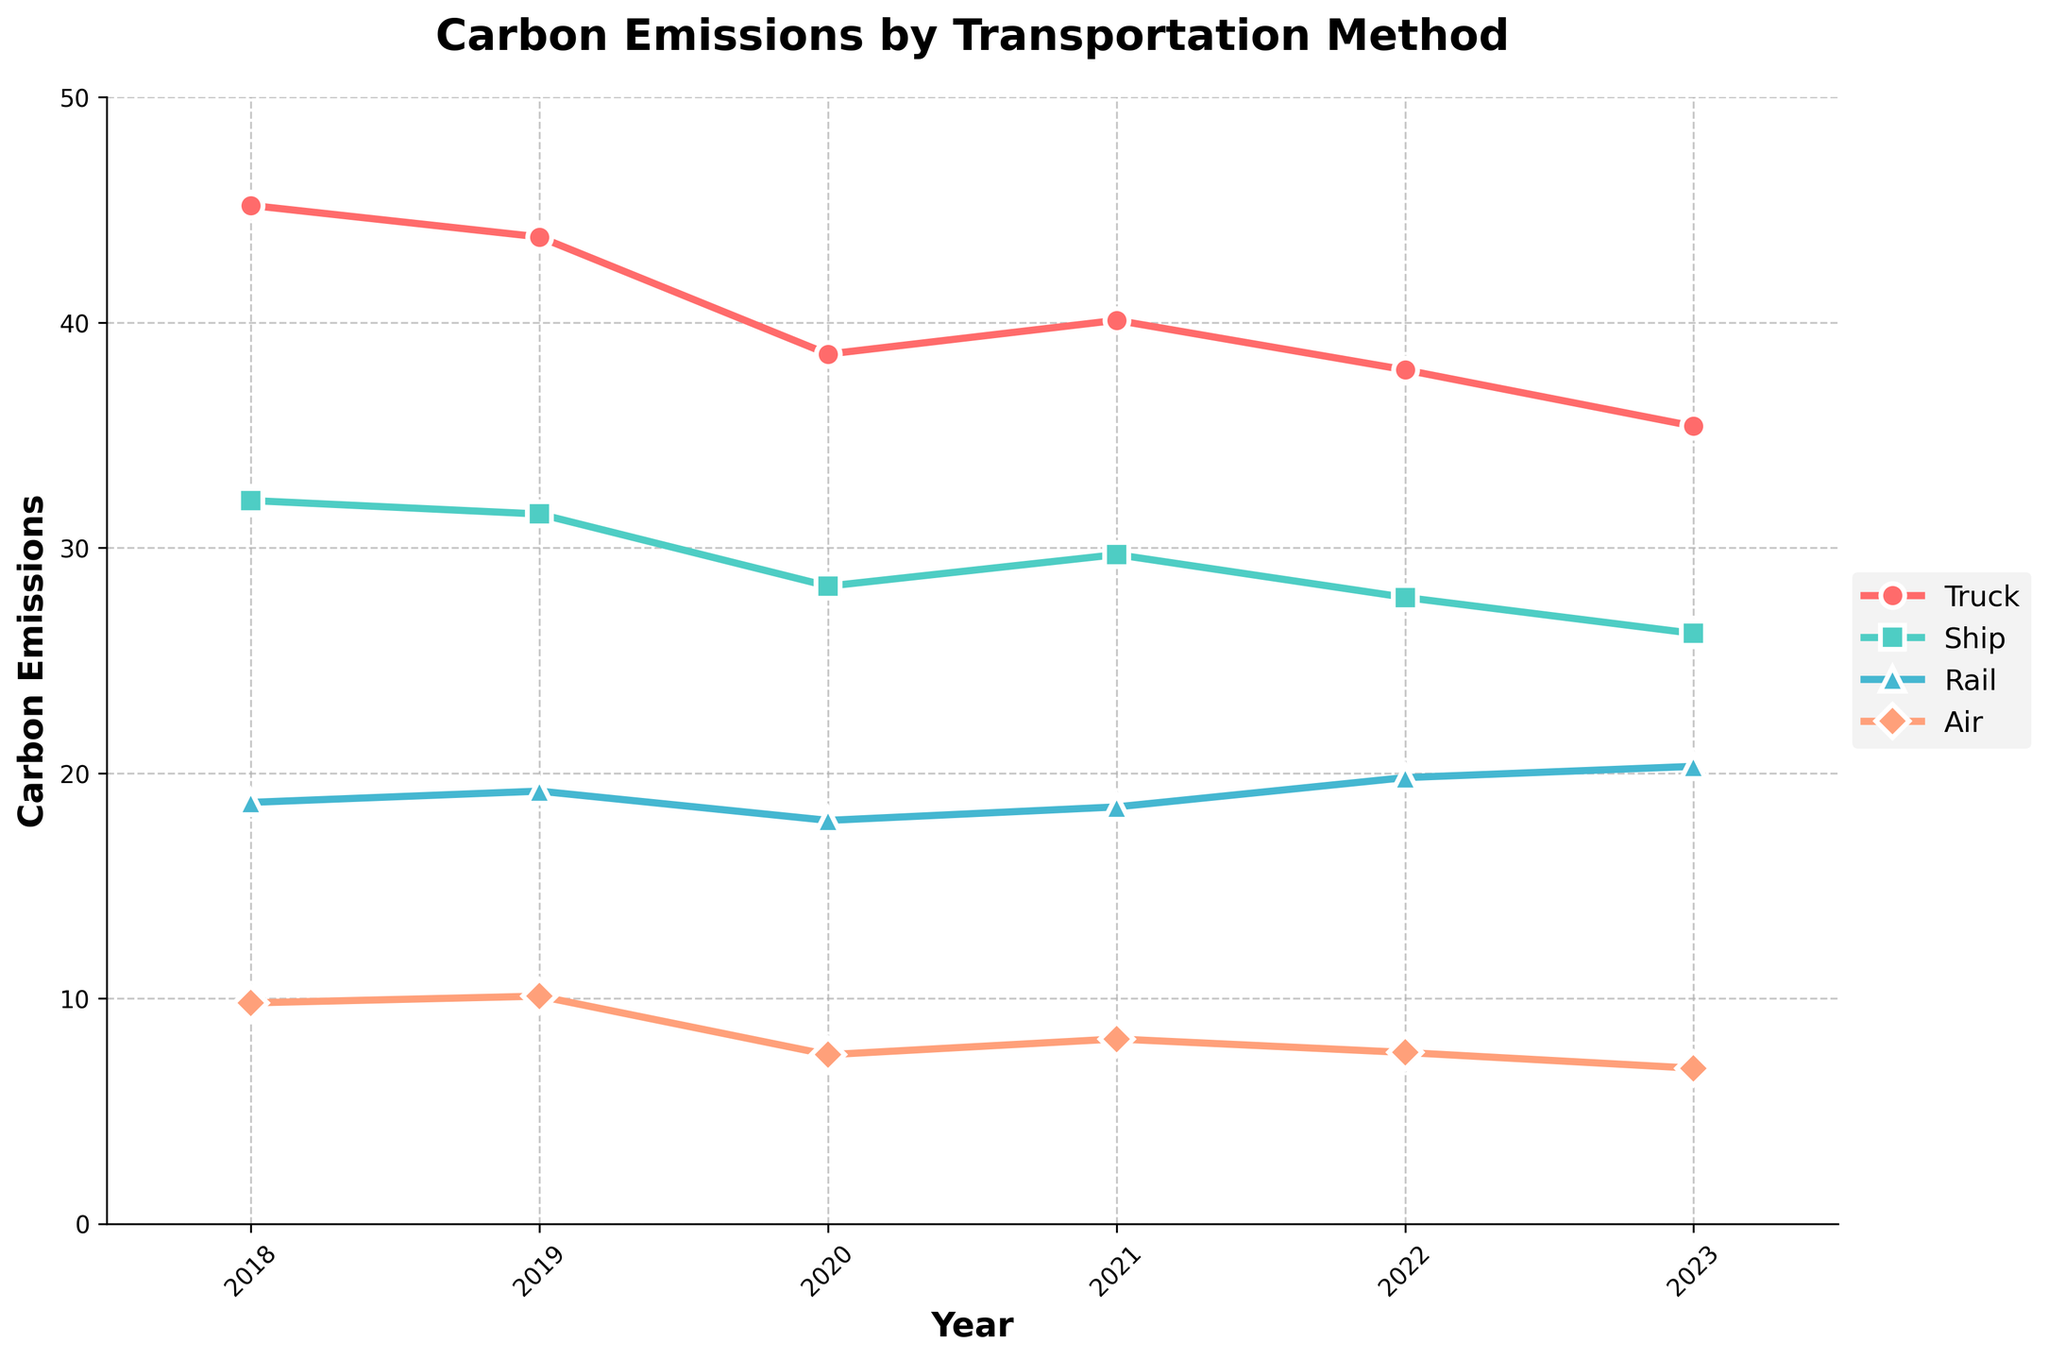How do the carbon emissions from Trucks in 2023 compare to those in 2018? The chart shows Truck emissions starting at 45.2 in 2018 and decreasing to 35.4 in 2023. To find the difference, subtract 35.4 from 45.2, which equals 9.8. This reduction indicates that emissions from Trucks have decreased from 2018 to 2023.
Answer: Decreased by 9.8 Which transportation method had the highest carbon emissions in 2023? Observing the final points in 2023 on the visualization, the Truck method has the highest value with 35.4.
Answer: Truck What is the trend of carbon emissions for Air transportation from 2018 to 2023? Air transportation emissions began at 9.8 in 2018, peaked at 10.1 in 2019, then fell consistently to 6.9 by 2023. This indicates an overall decreasing trend.
Answer: Decreasing In which year did Ship transportation method experience the lowest emissions? By examining the lines for Ship transportation, the lowest point occurs in 2023, reading 26.2 on the y-axis.
Answer: 2023 Compare the changes in Rail transportation emissions between 2020 and 2022. Did emissions increase or decrease? In 2020, Rail emissions were 17.9 and by 2022, they rose to 19.8. Therefore, emissions increased during this period.
Answer: Increased Which mode of transportation saw the smallest decrease in emissions from 2018 to 2023? The reduction for each method from 2018 to 2023 is calculated: Truck (9.8), Ship (5.9), Rail (1.6), Air (2.9). The smallest decrease is seen in Rail with a change of 1.6.
Answer: Rail What is the average carbon emission value for Ship transportation from 2018 to 2023? Sum the Ship emissions values (32.1 + 31.5 + 28.3 + 29.7 + 27.8 + 26.2 = 175.6) and divide by the number of years (6): 175.6 / 6 = 29.27.
Answer: 29.27 Which transportation method experienced the steepest decline in emissions from 2019 to 2020? The declines per method are: Truck (43.8 to 38.6 = -5.2), Ship (31.5 to 28.3 = -3.2), Rail (19.2 to 17.9 = -1.3), and Air (10.1 to 7.5 = -2.6). The steepest decline is observed in Truck with a drop of 5.2.
Answer: Truck What is the difference in emissions between the highest and lowest methods in 2021? Truck has the highest emissions in 2021 at 40.1, and Air the lowest at 8.2. The difference is calculated by subtracting 8.2 from 40.1, which equals 31.9.
Answer: 31.9 